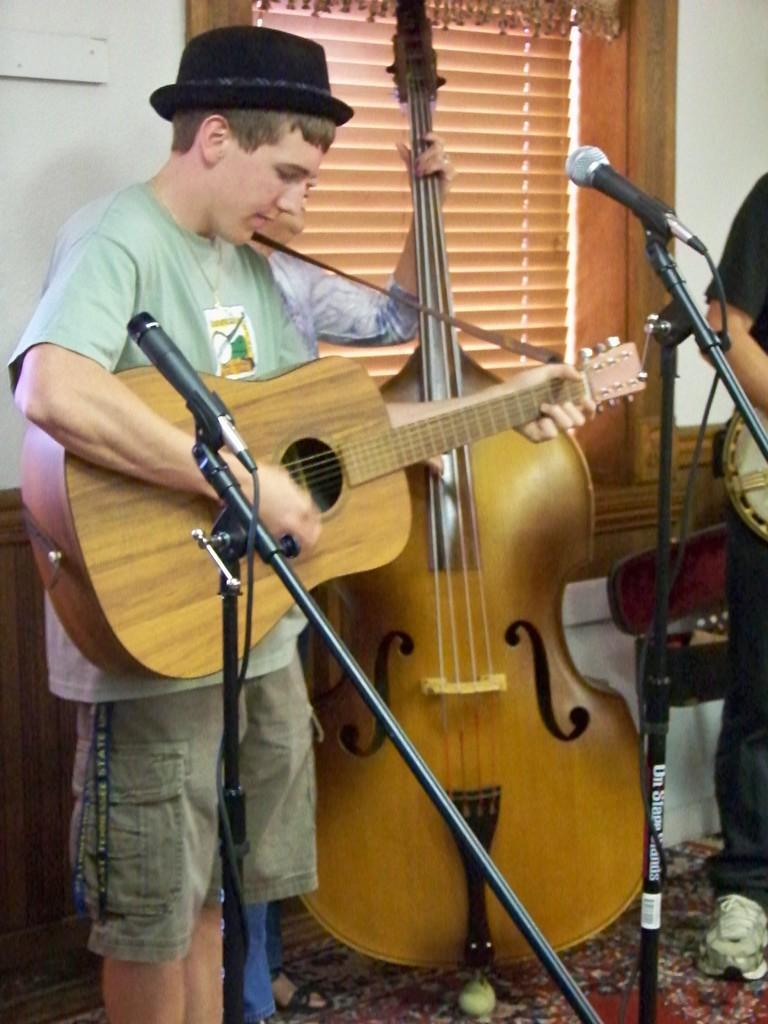Can you describe this image briefly? In the image few people are playing some musical instruments, Behind them there is a wall. In the middle of the image there is a microphone. 